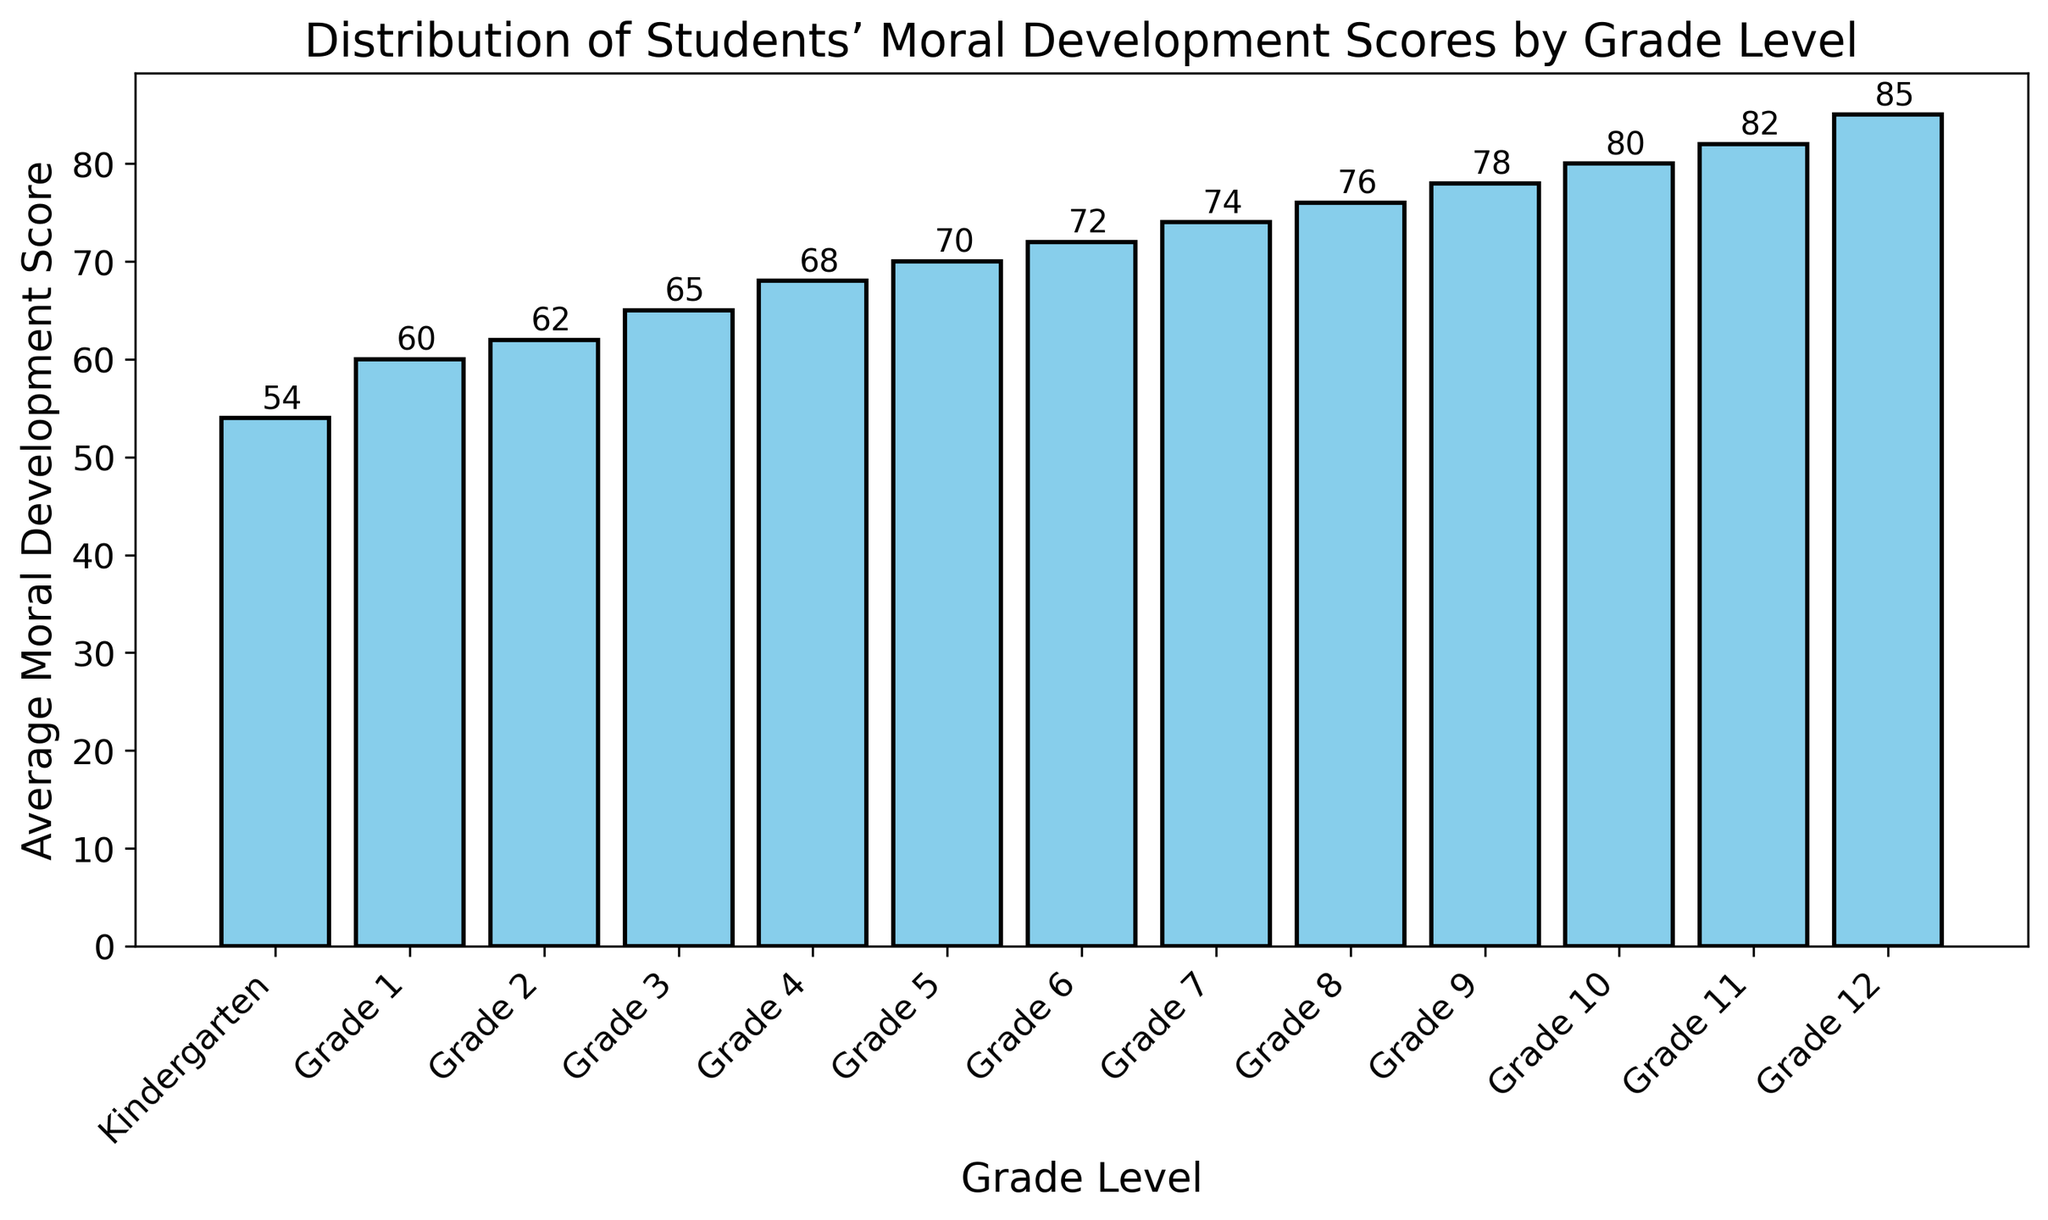What is the average moral development score for Grade 6? According to the bar chart, the average moral development score for Grade 6 is shown as 72.
Answer: 72 What is the difference in moral development scores between Grade 1 and Grade 12? The average moral development score for Grade 1 is 60, and for Grade 12 it is 85. To find the difference, subtract the Grade 1 score from the Grade 12 score: 85 - 60.
Answer: 25 Which grade has the highest average moral development score? By observing the heights of the bars in the chart, Grade 12 has the highest bar, indicating the highest score of 85.
Answer: Grade 12 Which grades have average moral development scores less than 70? Looking at the chart, the grades with scores less than 70 are Kindergarten, Grade 1, Grade 2, Grade 3, and Grade 4.
Answer: Kindergarten, Grade 1, Grade 2, Grade 3, and Grade 4 By how much did the average moral development score increase from Kindergarten to Grade 5? The average moral development score for Kindergarten is 54, and for Grade 5 it is 70. The increase is calculated as 70 - 54.
Answer: 16 On average, how much does the moral development score increase per grade level? To calculate this, take the difference between the average score in Grade 12 and Kindergarten, then divide by the number of intervals (12 grades): (85 - 54) / (12 - 1).
Answer: 2.818 Is the average score for Grade 10 closer to the score for Grade 8 or Grade 12? Comparing the differences: Grade 10 (80) is 4 points away from Grade 12 (80 - 85) and 4 points away from Grade 8 (80 - 76). Both differences are equal.
Answer: Both are equally close Which grade shows the first instance of an average moral development score reaching or exceeding 70? By examining the chart, Grade 5 is the first grade where the score reaches 70.
Answer: Grade 5 Identify the grade levels where the moral development scores show a color in the chart. The bars representing all the grade levels in the chart are colored in sky blue.
Answer: All grade levels 